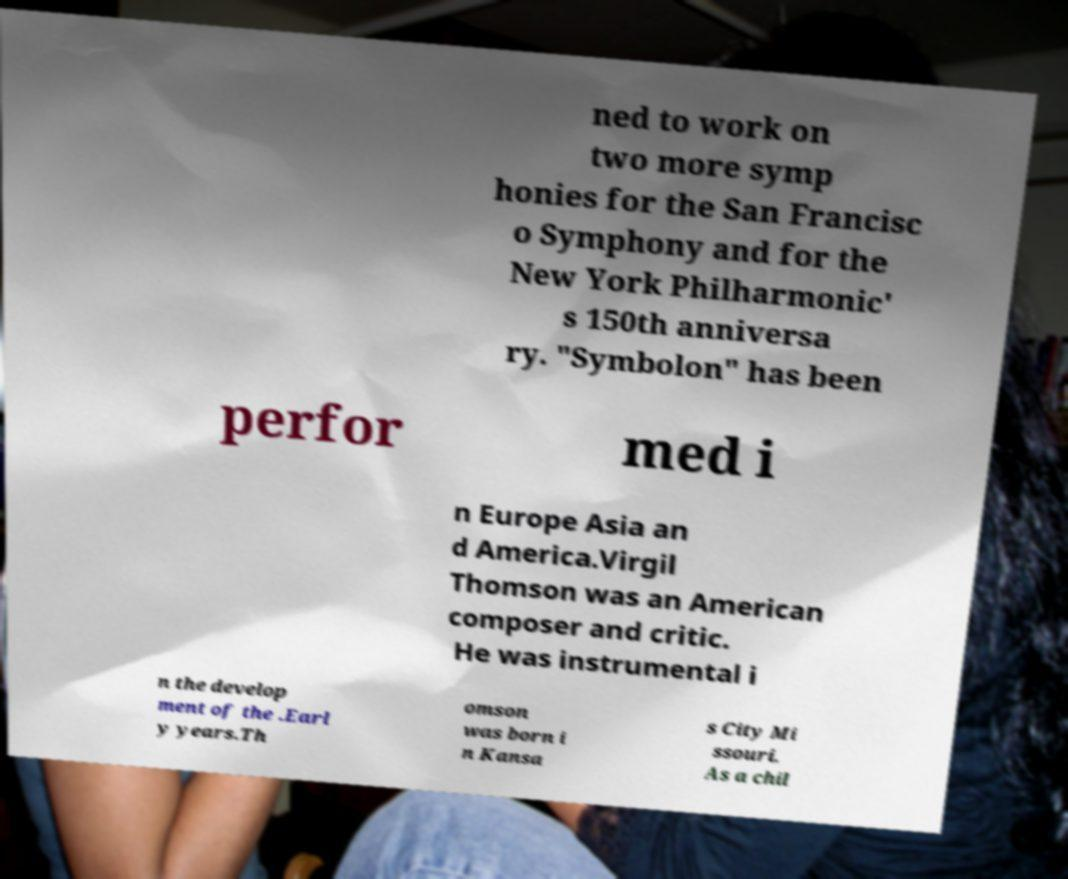Could you assist in decoding the text presented in this image and type it out clearly? ned to work on two more symp honies for the San Francisc o Symphony and for the New York Philharmonic' s 150th anniversa ry. "Symbolon" has been perfor med i n Europe Asia an d America.Virgil Thomson was an American composer and critic. He was instrumental i n the develop ment of the .Earl y years.Th omson was born i n Kansa s City Mi ssouri. As a chil 